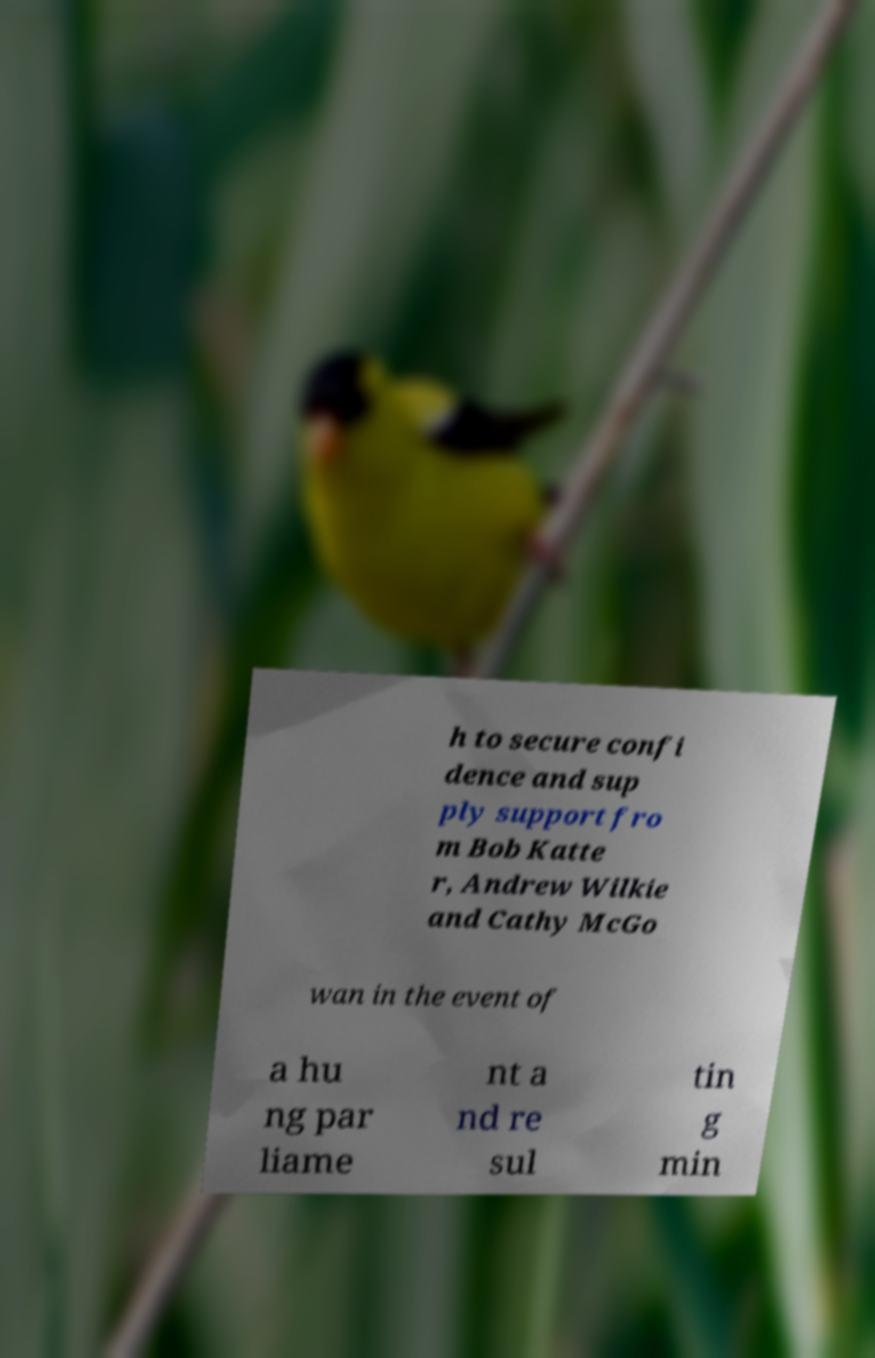Could you assist in decoding the text presented in this image and type it out clearly? h to secure confi dence and sup ply support fro m Bob Katte r, Andrew Wilkie and Cathy McGo wan in the event of a hu ng par liame nt a nd re sul tin g min 